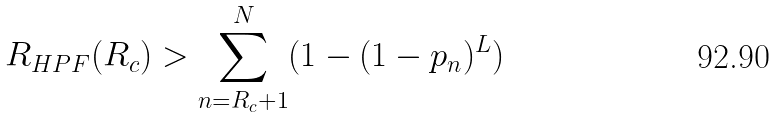Convert formula to latex. <formula><loc_0><loc_0><loc_500><loc_500>R _ { H P F } ( R _ { c } ) & > \sum _ { n = R _ { c } + 1 } ^ { N } ( 1 - ( 1 - p _ { n } ) ^ { L } )</formula> 